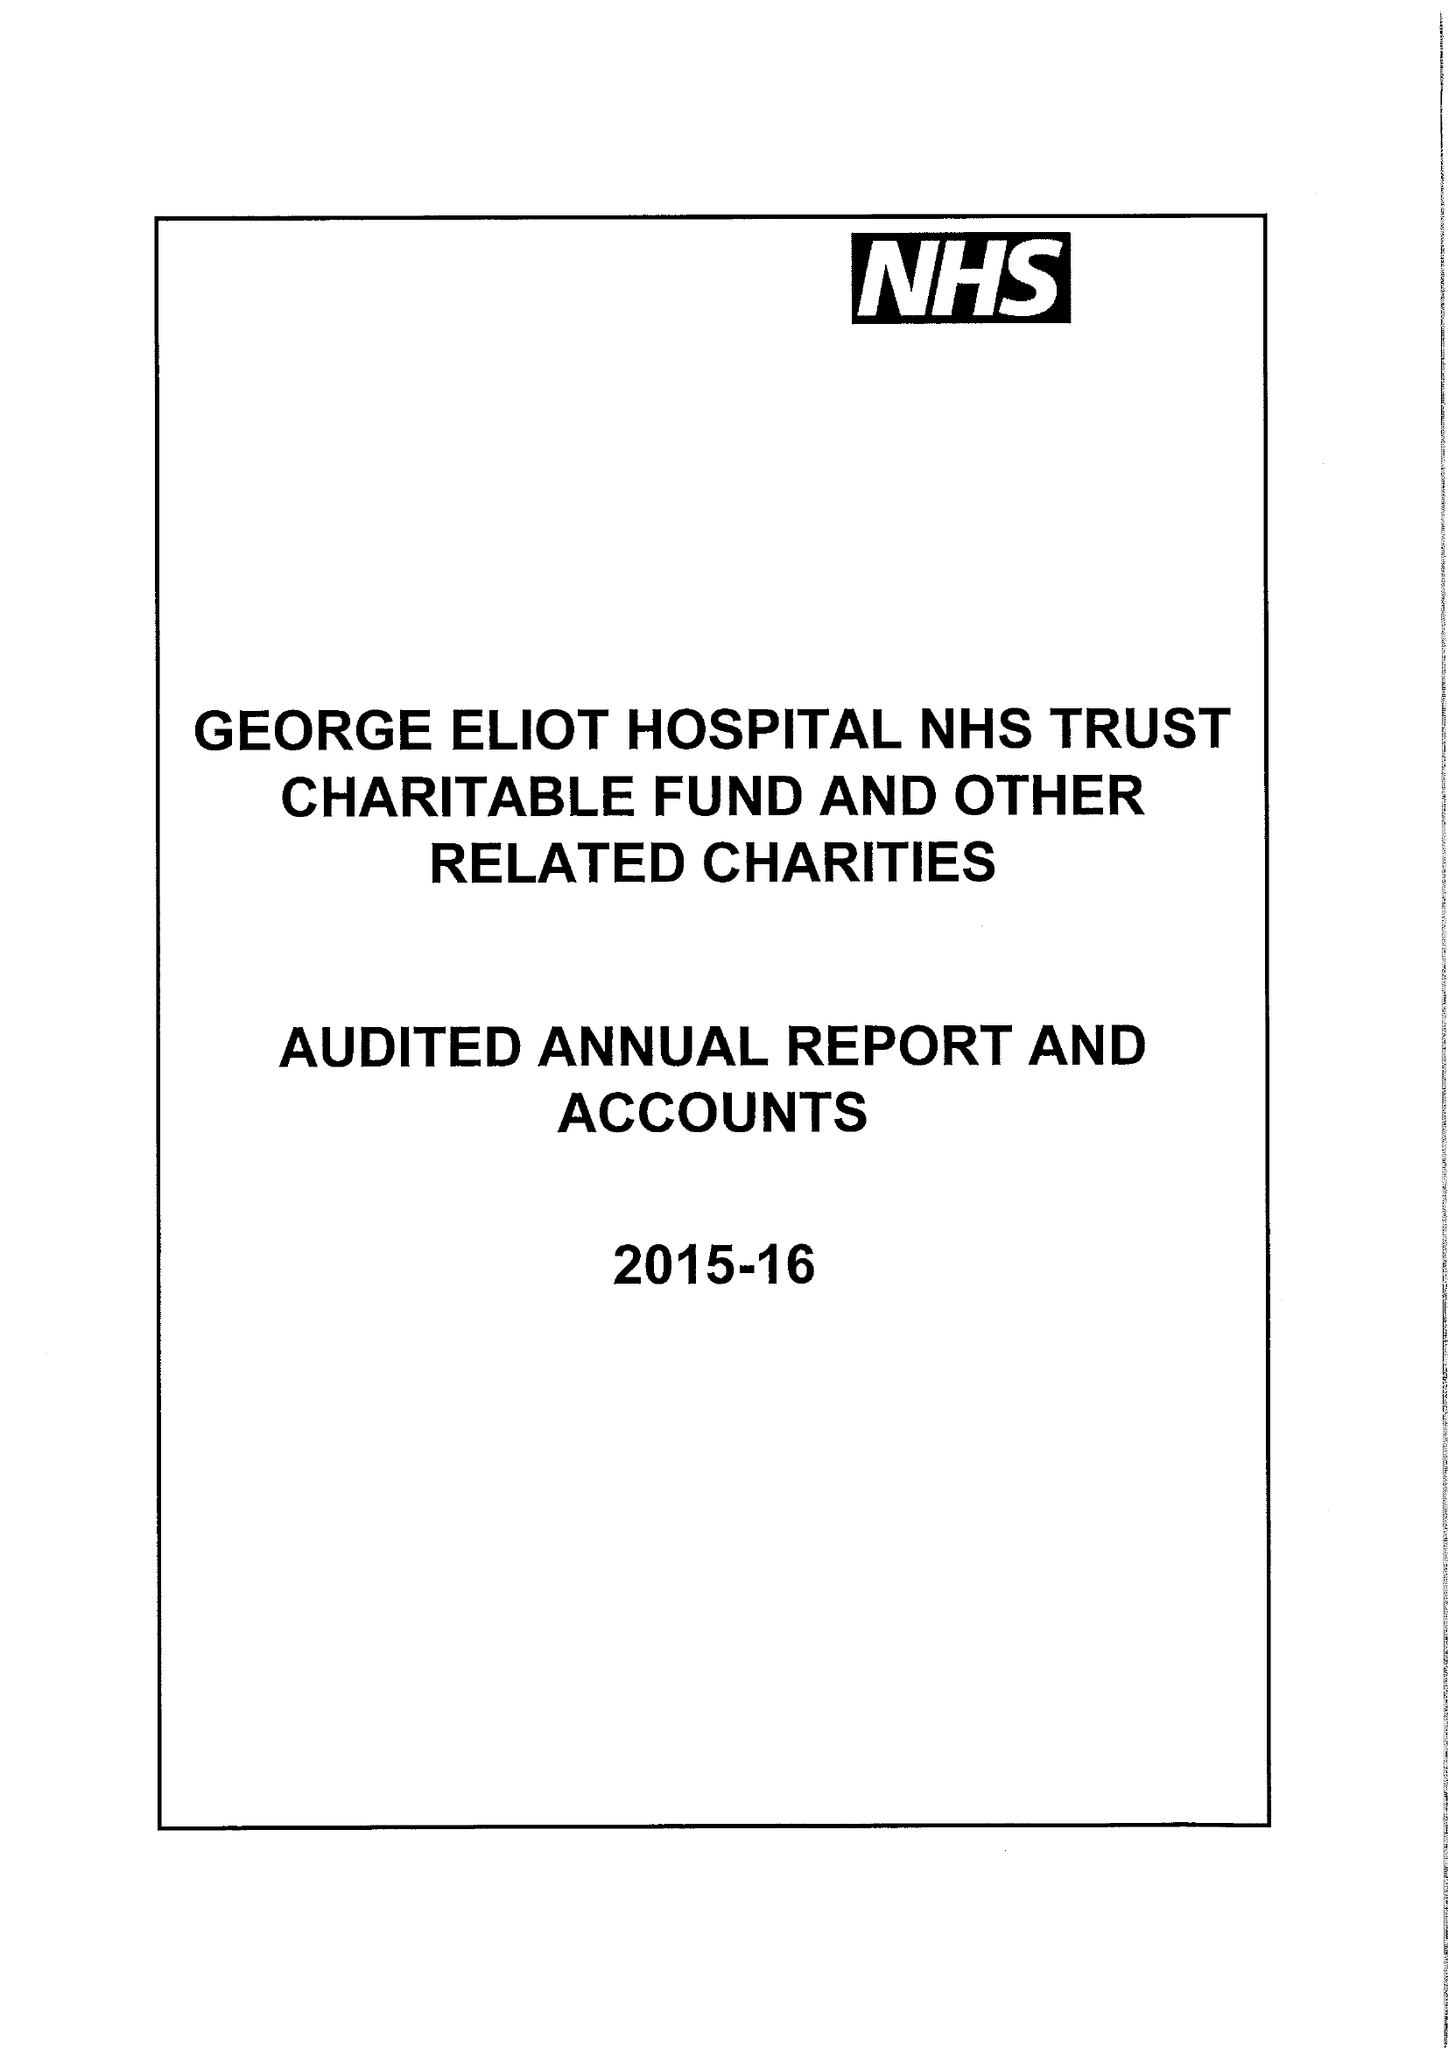What is the value for the address__post_town?
Answer the question using a single word or phrase. NUNEATON 